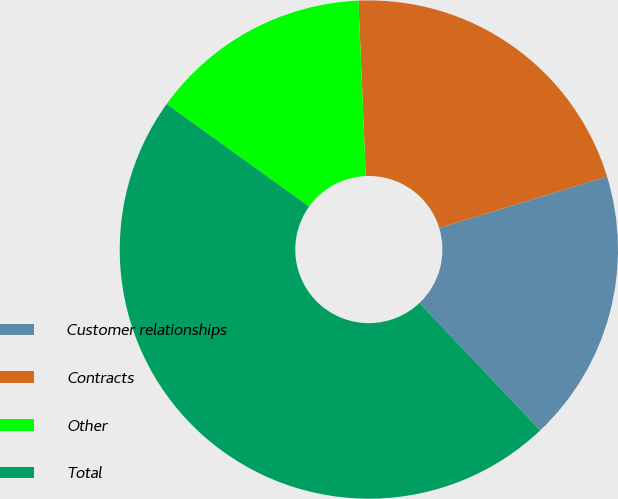<chart> <loc_0><loc_0><loc_500><loc_500><pie_chart><fcel>Customer relationships<fcel>Contracts<fcel>Other<fcel>Total<nl><fcel>17.67%<fcel>20.93%<fcel>14.41%<fcel>47.0%<nl></chart> 